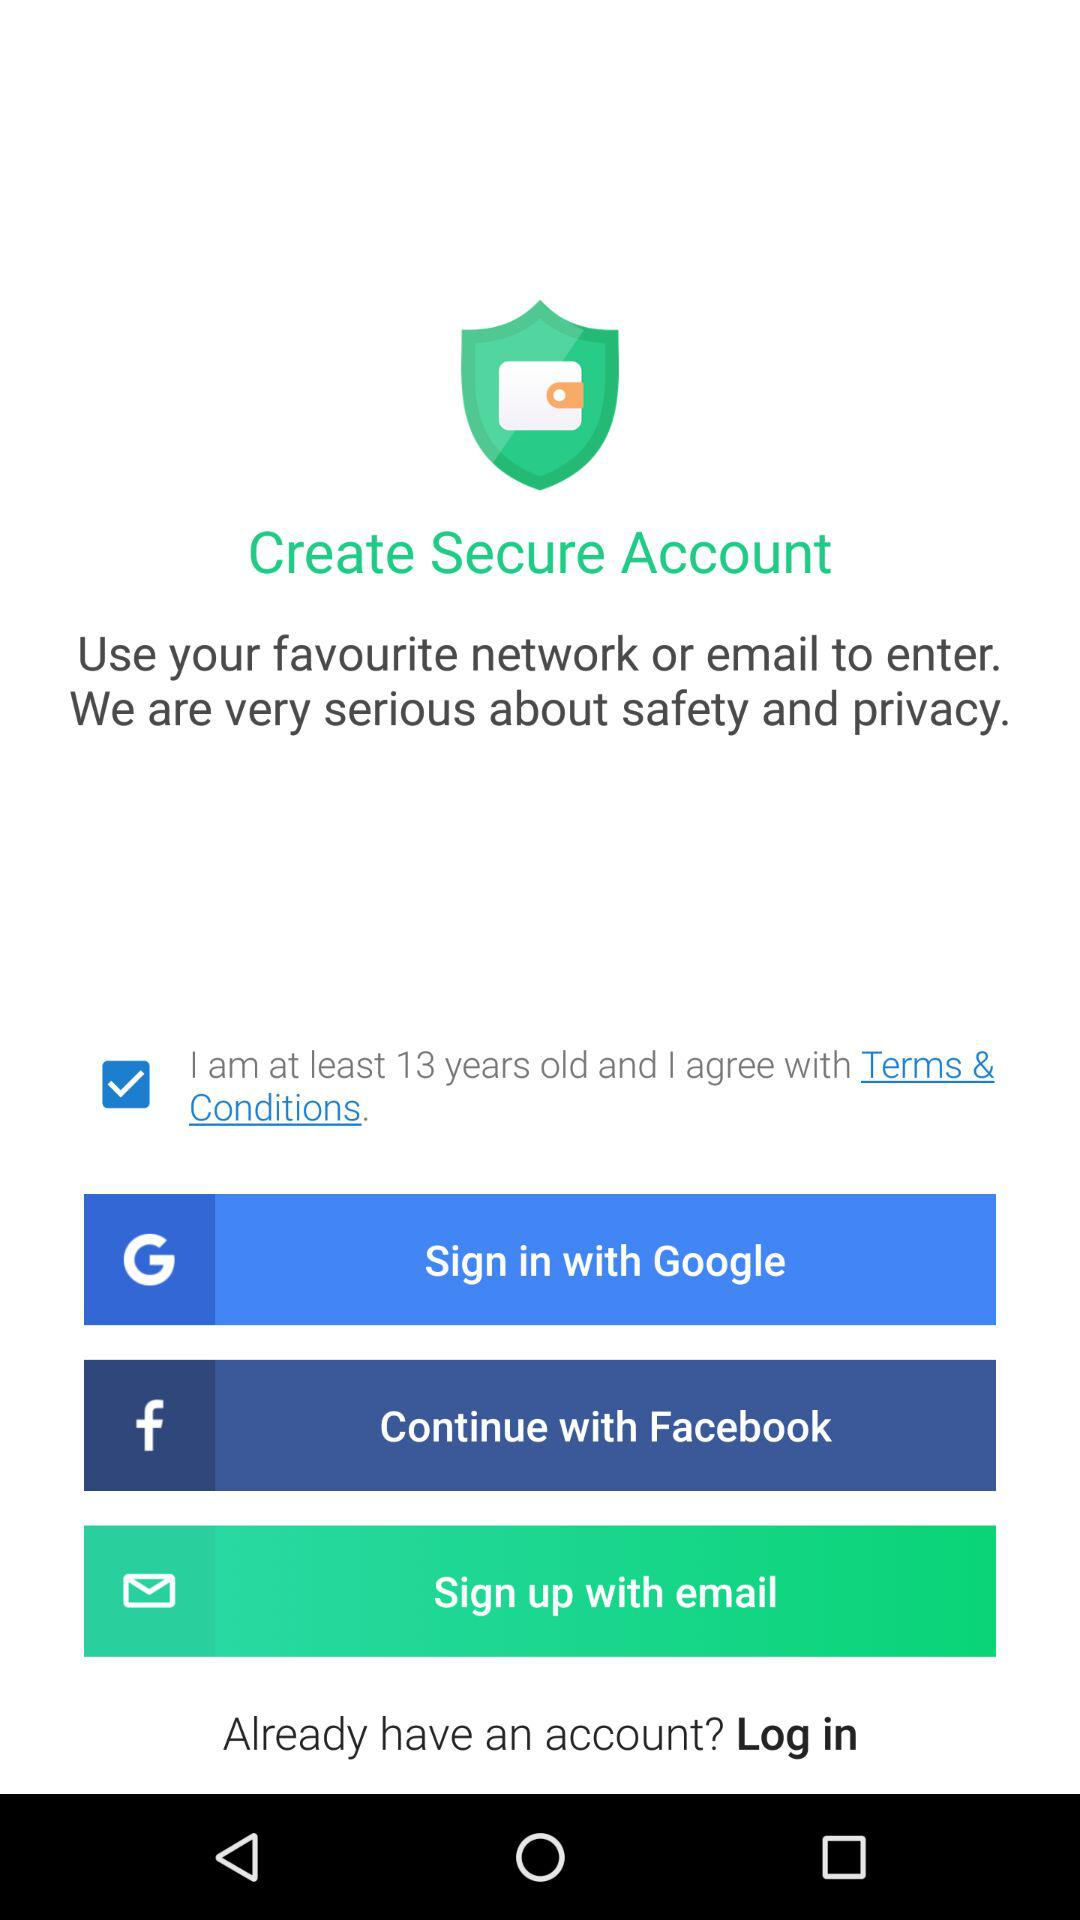What are the terms and conditions?
When the provided information is insufficient, respond with <no answer>. <no answer> 